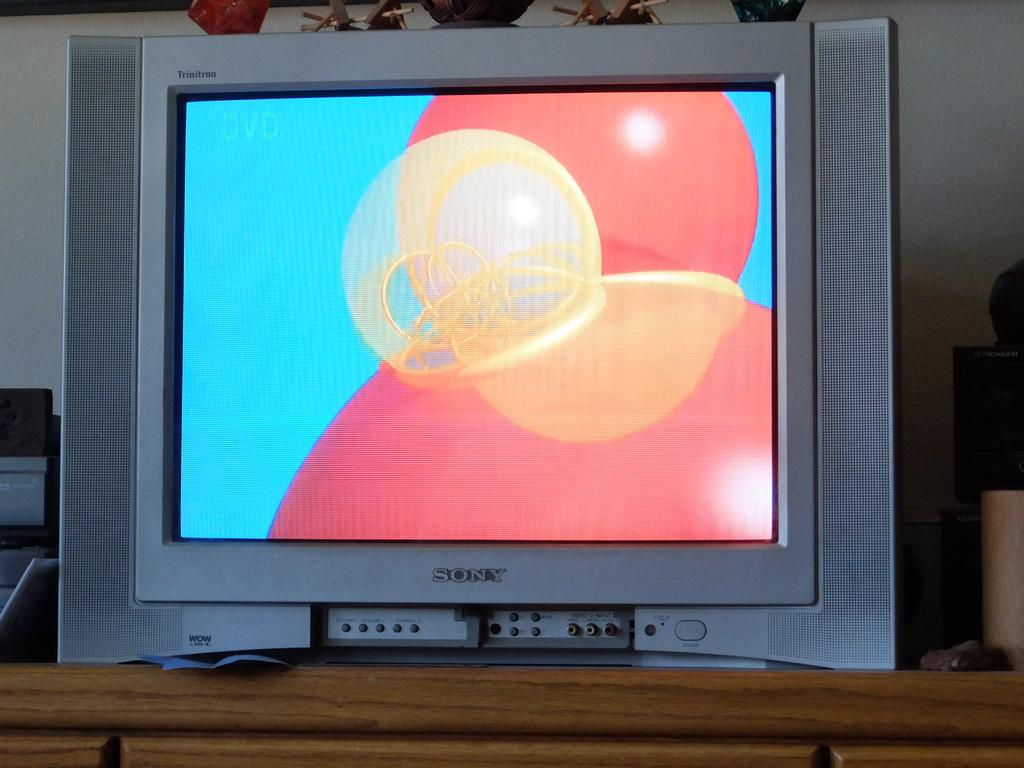<image>
Create a compact narrative representing the image presented. A colorful design on the screen of a Sony television. 